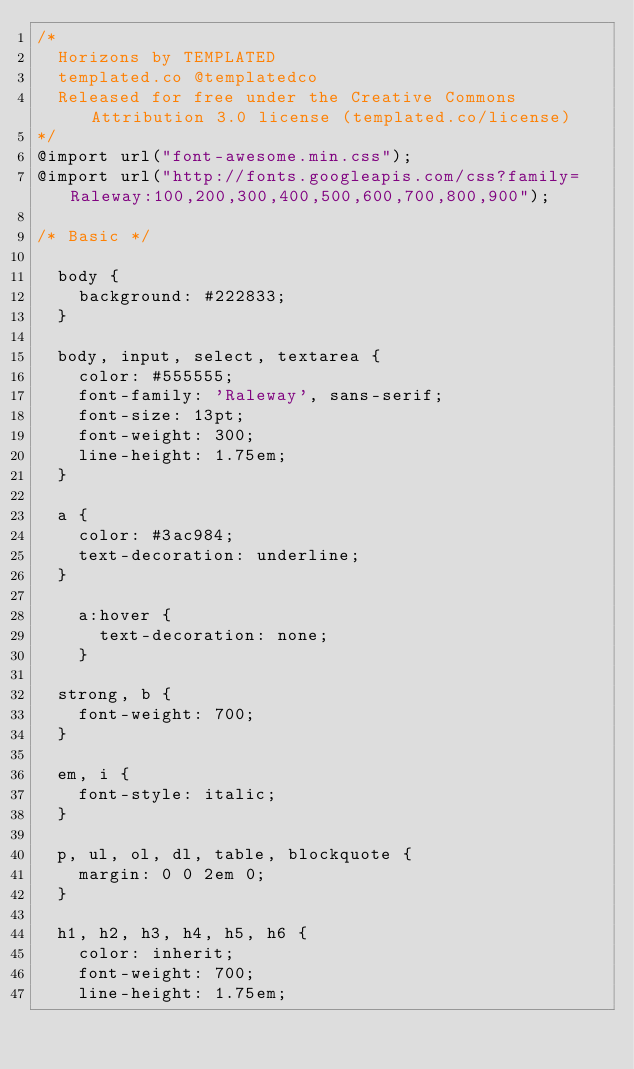Convert code to text. <code><loc_0><loc_0><loc_500><loc_500><_CSS_>/*
	Horizons by TEMPLATED
	templated.co @templatedco
	Released for free under the Creative Commons Attribution 3.0 license (templated.co/license)
*/
@import url("font-awesome.min.css");
@import url("http://fonts.googleapis.com/css?family=Raleway:100,200,300,400,500,600,700,800,900");

/* Basic */

	body {
		background: #222833;
	}

	body, input, select, textarea {
		color: #555555;
		font-family: 'Raleway', sans-serif;
		font-size: 13pt;
		font-weight: 300;
		line-height: 1.75em;
	}

	a {
		color: #3ac984;
		text-decoration: underline;
	}

		a:hover {
			text-decoration: none;
		}

	strong, b {
		font-weight: 700;
	}

	em, i {
		font-style: italic;
	}

	p, ul, ol, dl, table, blockquote {
		margin: 0 0 2em 0;
	}

	h1, h2, h3, h4, h5, h6 {
		color: inherit;
		font-weight: 700;
		line-height: 1.75em;</code> 